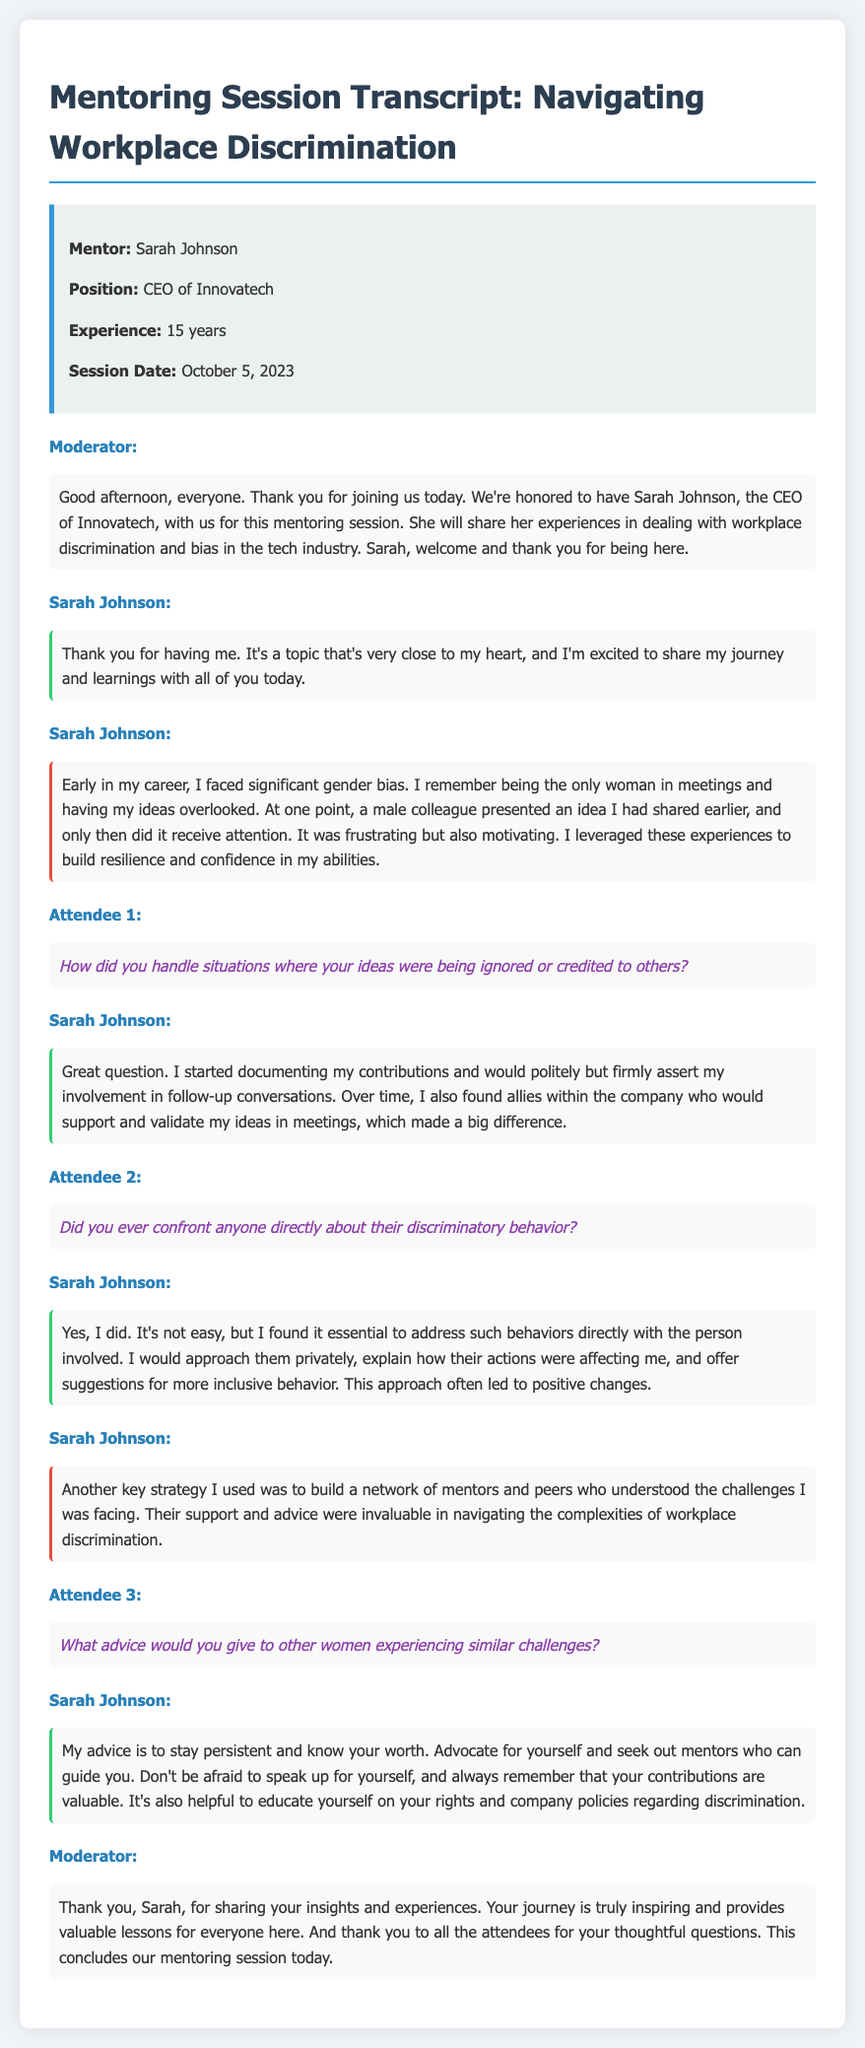what is the name of the mentor? The mentor's name is mentioned at the beginning of the document, which is Sarah Johnson.
Answer: Sarah Johnson what is Sarah Johnson's position? Sarah Johnson's position is stated in the mentor info section.
Answer: CEO of Innovatech how many years of experience does Sarah Johnson have? The document specifies that Sarah Johnson has 15 years of experience.
Answer: 15 years when was the session held? The date of the session is clearly indicated in the mentor info section.
Answer: October 5, 2023 who asked about confronting discriminatory behavior? The identity of the attendee asking a question about confronting discrimination is noted in the transcript.
Answer: Attendee 2 what approach did Sarah Johnson recommend for handling ignored ideas? Sarah suggests documenting contributions and asserting involvement in follow-ups.
Answer: Documenting contributions what does Sarah Johnson advise women experiencing challenges? The advice Sarah Johnson gives to other women is outlined in her response.
Answer: Stay persistent and know your worth how does Sarah Johnson describe her early career experience? She shares her experiences during her early career in the transcription.
Answer: Significant gender bias 